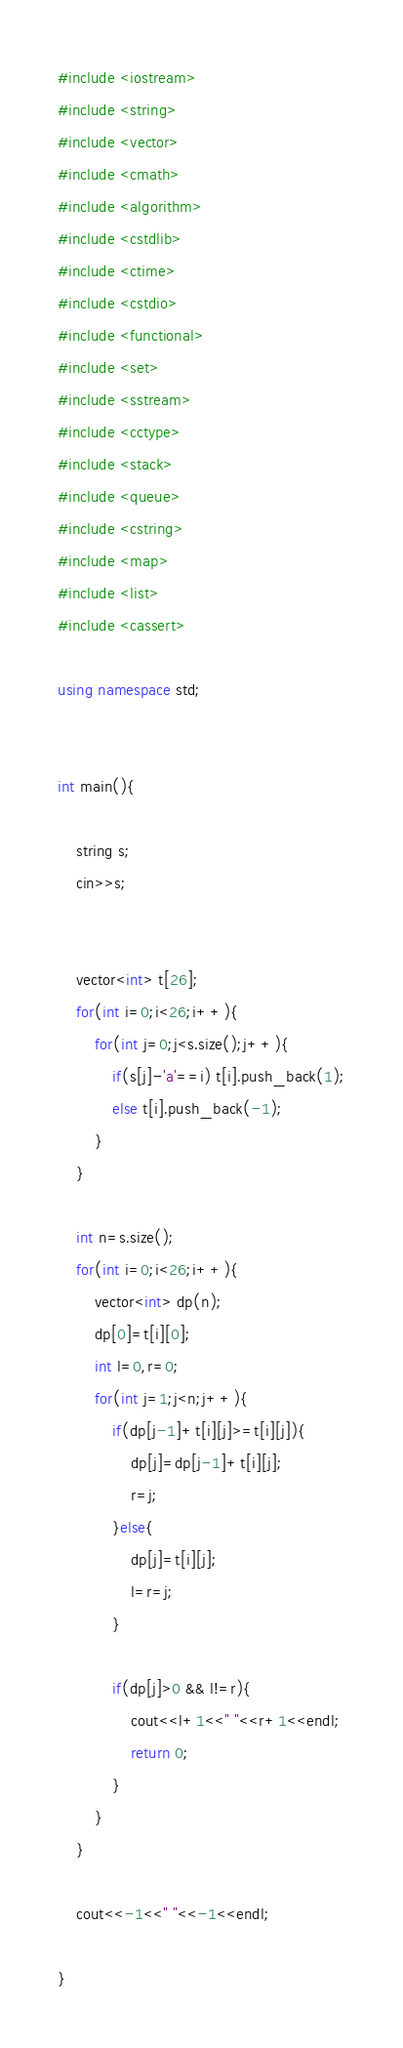<code> <loc_0><loc_0><loc_500><loc_500><_C++_>#include <iostream> 
#include <string> 
#include <vector> 
#include <cmath> 
#include <algorithm> 
#include <cstdlib> 
#include <ctime> 
#include <cstdio> 
#include <functional> 
#include <set> 
#include <sstream> 
#include <cctype>
#include <stack>
#include <queue>
#include <cstring>
#include <map>
#include <list>
#include <cassert>
 
using namespace std; 


int main(){

	string s;
	cin>>s;


	vector<int> t[26];
	for(int i=0;i<26;i++){
		for(int j=0;j<s.size();j++){
			if(s[j]-'a'==i) t[i].push_back(1);
			else t[i].push_back(-1);
		}
	}

	int n=s.size();
	for(int i=0;i<26;i++){
		vector<int> dp(n);
		dp[0]=t[i][0];
		int l=0,r=0;
		for(int j=1;j<n;j++){
			if(dp[j-1]+t[i][j]>=t[i][j]){
				dp[j]=dp[j-1]+t[i][j];
				r=j;
			}else{
				dp[j]=t[i][j];
				l=r=j;
			}

			if(dp[j]>0 && l!=r){
				cout<<l+1<<" "<<r+1<<endl;
				return 0;
			}
		}
	}

	cout<<-1<<" "<<-1<<endl;

}</code> 